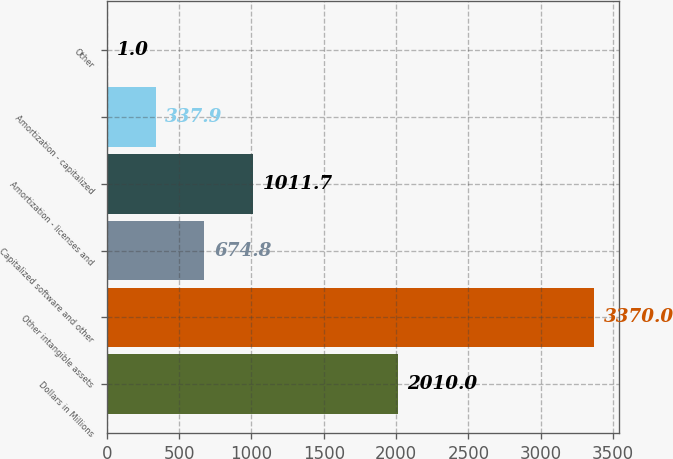Convert chart. <chart><loc_0><loc_0><loc_500><loc_500><bar_chart><fcel>Dollars in Millions<fcel>Other intangible assets<fcel>Capitalized software and other<fcel>Amortization - licenses and<fcel>Amortization - capitalized<fcel>Other<nl><fcel>2010<fcel>3370<fcel>674.8<fcel>1011.7<fcel>337.9<fcel>1<nl></chart> 